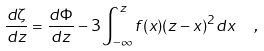<formula> <loc_0><loc_0><loc_500><loc_500>\frac { d \zeta } { d z } = \frac { d \Phi } { d z } - 3 \int _ { - \infty } ^ { z } f ( x ) ( z - x ) ^ { 2 } d x \ \ ,</formula> 